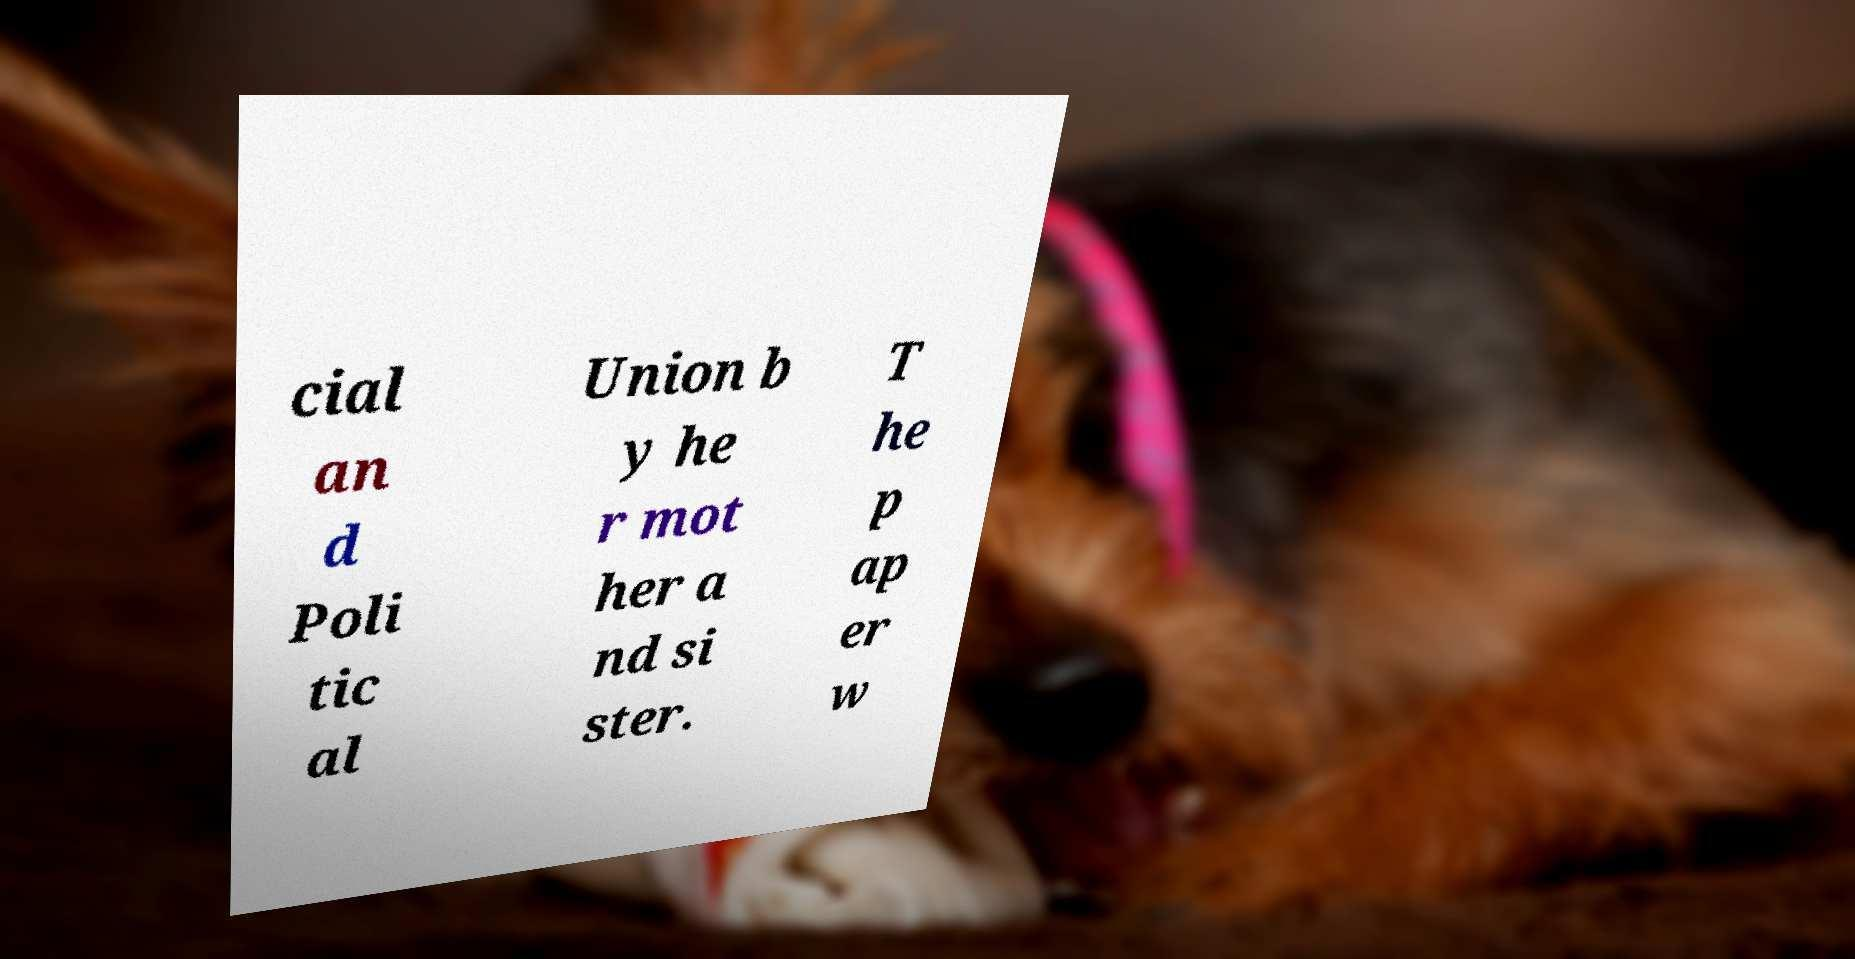Please read and relay the text visible in this image. What does it say? cial an d Poli tic al Union b y he r mot her a nd si ster. T he p ap er w 